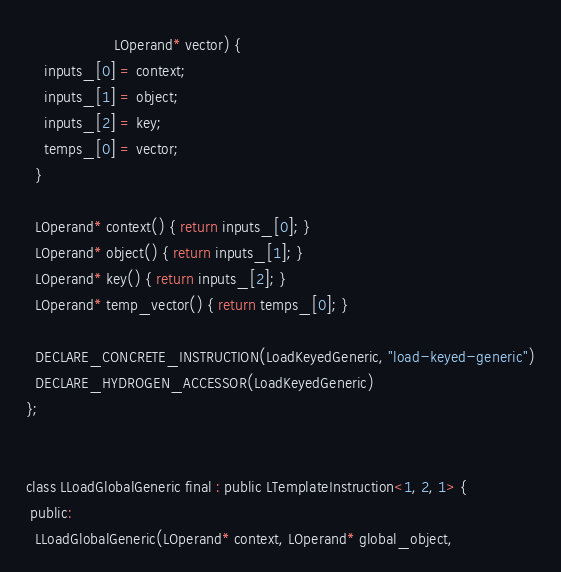Convert code to text. <code><loc_0><loc_0><loc_500><loc_500><_C_>                    LOperand* vector) {
    inputs_[0] = context;
    inputs_[1] = object;
    inputs_[2] = key;
    temps_[0] = vector;
  }

  LOperand* context() { return inputs_[0]; }
  LOperand* object() { return inputs_[1]; }
  LOperand* key() { return inputs_[2]; }
  LOperand* temp_vector() { return temps_[0]; }

  DECLARE_CONCRETE_INSTRUCTION(LoadKeyedGeneric, "load-keyed-generic")
  DECLARE_HYDROGEN_ACCESSOR(LoadKeyedGeneric)
};


class LLoadGlobalGeneric final : public LTemplateInstruction<1, 2, 1> {
 public:
  LLoadGlobalGeneric(LOperand* context, LOperand* global_object,</code> 